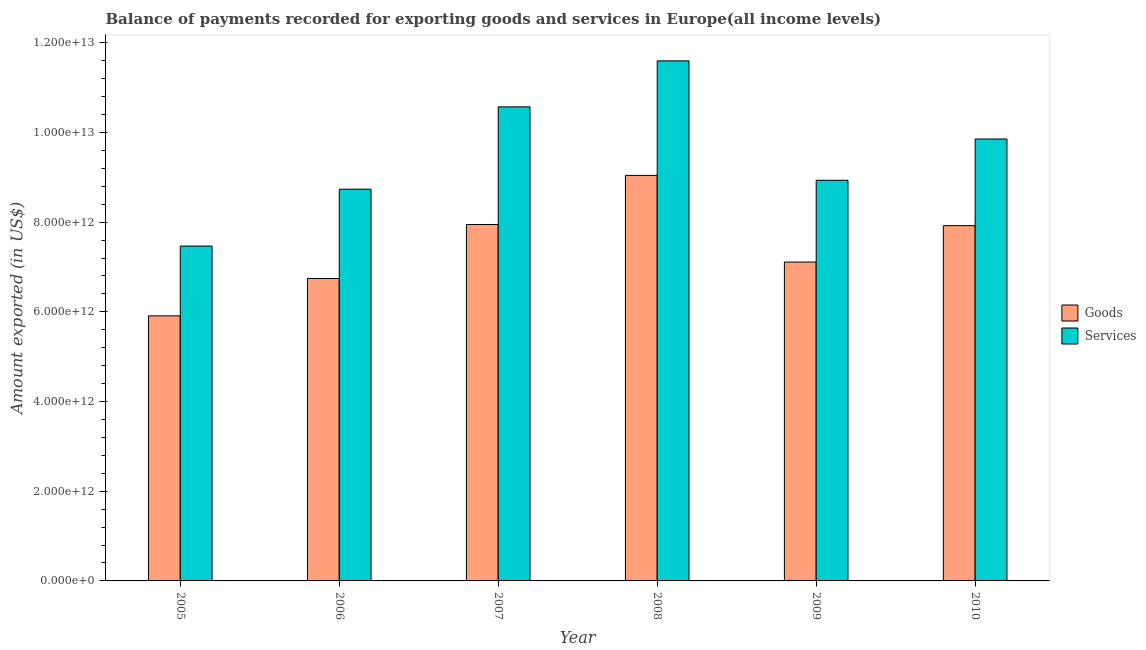Are the number of bars per tick equal to the number of legend labels?
Provide a short and direct response. Yes. Are the number of bars on each tick of the X-axis equal?
Keep it short and to the point. Yes. How many bars are there on the 5th tick from the right?
Keep it short and to the point. 2. What is the label of the 1st group of bars from the left?
Provide a succinct answer. 2005. What is the amount of goods exported in 2010?
Provide a short and direct response. 7.92e+12. Across all years, what is the maximum amount of goods exported?
Your answer should be compact. 9.04e+12. Across all years, what is the minimum amount of goods exported?
Your answer should be compact. 5.91e+12. What is the total amount of goods exported in the graph?
Offer a very short reply. 4.47e+13. What is the difference between the amount of goods exported in 2006 and that in 2010?
Keep it short and to the point. -1.18e+12. What is the difference between the amount of services exported in 2006 and the amount of goods exported in 2007?
Keep it short and to the point. -1.84e+12. What is the average amount of services exported per year?
Offer a terse response. 9.53e+12. What is the ratio of the amount of services exported in 2005 to that in 2008?
Offer a very short reply. 0.64. Is the amount of goods exported in 2006 less than that in 2010?
Offer a very short reply. Yes. Is the difference between the amount of services exported in 2009 and 2010 greater than the difference between the amount of goods exported in 2009 and 2010?
Ensure brevity in your answer.  No. What is the difference between the highest and the second highest amount of services exported?
Offer a very short reply. 1.03e+12. What is the difference between the highest and the lowest amount of services exported?
Give a very brief answer. 4.13e+12. What does the 2nd bar from the left in 2007 represents?
Your answer should be compact. Services. What does the 2nd bar from the right in 2007 represents?
Provide a succinct answer. Goods. How many years are there in the graph?
Keep it short and to the point. 6. What is the difference between two consecutive major ticks on the Y-axis?
Offer a terse response. 2.00e+12. Are the values on the major ticks of Y-axis written in scientific E-notation?
Provide a succinct answer. Yes. Does the graph contain any zero values?
Offer a very short reply. No. Does the graph contain grids?
Offer a terse response. No. Where does the legend appear in the graph?
Your answer should be very brief. Center right. How many legend labels are there?
Keep it short and to the point. 2. How are the legend labels stacked?
Offer a very short reply. Vertical. What is the title of the graph?
Make the answer very short. Balance of payments recorded for exporting goods and services in Europe(all income levels). Does "Rural" appear as one of the legend labels in the graph?
Give a very brief answer. No. What is the label or title of the Y-axis?
Provide a short and direct response. Amount exported (in US$). What is the Amount exported (in US$) of Goods in 2005?
Give a very brief answer. 5.91e+12. What is the Amount exported (in US$) of Services in 2005?
Your response must be concise. 7.47e+12. What is the Amount exported (in US$) of Goods in 2006?
Provide a succinct answer. 6.74e+12. What is the Amount exported (in US$) of Services in 2006?
Make the answer very short. 8.74e+12. What is the Amount exported (in US$) in Goods in 2007?
Ensure brevity in your answer.  7.95e+12. What is the Amount exported (in US$) in Services in 2007?
Your answer should be very brief. 1.06e+13. What is the Amount exported (in US$) in Goods in 2008?
Make the answer very short. 9.04e+12. What is the Amount exported (in US$) in Services in 2008?
Offer a terse response. 1.16e+13. What is the Amount exported (in US$) of Goods in 2009?
Your answer should be very brief. 7.11e+12. What is the Amount exported (in US$) of Services in 2009?
Provide a succinct answer. 8.93e+12. What is the Amount exported (in US$) in Goods in 2010?
Your response must be concise. 7.92e+12. What is the Amount exported (in US$) in Services in 2010?
Your response must be concise. 9.86e+12. Across all years, what is the maximum Amount exported (in US$) in Goods?
Keep it short and to the point. 9.04e+12. Across all years, what is the maximum Amount exported (in US$) in Services?
Offer a terse response. 1.16e+13. Across all years, what is the minimum Amount exported (in US$) of Goods?
Provide a short and direct response. 5.91e+12. Across all years, what is the minimum Amount exported (in US$) in Services?
Give a very brief answer. 7.47e+12. What is the total Amount exported (in US$) of Goods in the graph?
Ensure brevity in your answer.  4.47e+13. What is the total Amount exported (in US$) of Services in the graph?
Ensure brevity in your answer.  5.72e+13. What is the difference between the Amount exported (in US$) in Goods in 2005 and that in 2006?
Make the answer very short. -8.34e+11. What is the difference between the Amount exported (in US$) of Services in 2005 and that in 2006?
Keep it short and to the point. -1.27e+12. What is the difference between the Amount exported (in US$) of Goods in 2005 and that in 2007?
Offer a very short reply. -2.04e+12. What is the difference between the Amount exported (in US$) in Services in 2005 and that in 2007?
Provide a succinct answer. -3.10e+12. What is the difference between the Amount exported (in US$) of Goods in 2005 and that in 2008?
Offer a very short reply. -3.13e+12. What is the difference between the Amount exported (in US$) of Services in 2005 and that in 2008?
Provide a short and direct response. -4.13e+12. What is the difference between the Amount exported (in US$) of Goods in 2005 and that in 2009?
Provide a succinct answer. -1.20e+12. What is the difference between the Amount exported (in US$) of Services in 2005 and that in 2009?
Make the answer very short. -1.47e+12. What is the difference between the Amount exported (in US$) in Goods in 2005 and that in 2010?
Make the answer very short. -2.01e+12. What is the difference between the Amount exported (in US$) of Services in 2005 and that in 2010?
Provide a succinct answer. -2.39e+12. What is the difference between the Amount exported (in US$) of Goods in 2006 and that in 2007?
Your response must be concise. -1.20e+12. What is the difference between the Amount exported (in US$) of Services in 2006 and that in 2007?
Give a very brief answer. -1.84e+12. What is the difference between the Amount exported (in US$) in Goods in 2006 and that in 2008?
Your answer should be very brief. -2.30e+12. What is the difference between the Amount exported (in US$) of Services in 2006 and that in 2008?
Make the answer very short. -2.86e+12. What is the difference between the Amount exported (in US$) of Goods in 2006 and that in 2009?
Make the answer very short. -3.67e+11. What is the difference between the Amount exported (in US$) of Services in 2006 and that in 2009?
Your response must be concise. -1.99e+11. What is the difference between the Amount exported (in US$) of Goods in 2006 and that in 2010?
Provide a short and direct response. -1.18e+12. What is the difference between the Amount exported (in US$) in Services in 2006 and that in 2010?
Offer a very short reply. -1.12e+12. What is the difference between the Amount exported (in US$) in Goods in 2007 and that in 2008?
Your response must be concise. -1.09e+12. What is the difference between the Amount exported (in US$) of Services in 2007 and that in 2008?
Give a very brief answer. -1.03e+12. What is the difference between the Amount exported (in US$) of Goods in 2007 and that in 2009?
Your answer should be compact. 8.38e+11. What is the difference between the Amount exported (in US$) in Services in 2007 and that in 2009?
Provide a short and direct response. 1.64e+12. What is the difference between the Amount exported (in US$) of Goods in 2007 and that in 2010?
Keep it short and to the point. 2.57e+1. What is the difference between the Amount exported (in US$) of Services in 2007 and that in 2010?
Ensure brevity in your answer.  7.16e+11. What is the difference between the Amount exported (in US$) in Goods in 2008 and that in 2009?
Your answer should be very brief. 1.93e+12. What is the difference between the Amount exported (in US$) of Services in 2008 and that in 2009?
Your response must be concise. 2.66e+12. What is the difference between the Amount exported (in US$) of Goods in 2008 and that in 2010?
Keep it short and to the point. 1.12e+12. What is the difference between the Amount exported (in US$) of Services in 2008 and that in 2010?
Give a very brief answer. 1.74e+12. What is the difference between the Amount exported (in US$) in Goods in 2009 and that in 2010?
Give a very brief answer. -8.12e+11. What is the difference between the Amount exported (in US$) of Services in 2009 and that in 2010?
Your answer should be very brief. -9.21e+11. What is the difference between the Amount exported (in US$) in Goods in 2005 and the Amount exported (in US$) in Services in 2006?
Give a very brief answer. -2.82e+12. What is the difference between the Amount exported (in US$) in Goods in 2005 and the Amount exported (in US$) in Services in 2007?
Keep it short and to the point. -4.66e+12. What is the difference between the Amount exported (in US$) of Goods in 2005 and the Amount exported (in US$) of Services in 2008?
Give a very brief answer. -5.69e+12. What is the difference between the Amount exported (in US$) of Goods in 2005 and the Amount exported (in US$) of Services in 2009?
Ensure brevity in your answer.  -3.02e+12. What is the difference between the Amount exported (in US$) in Goods in 2005 and the Amount exported (in US$) in Services in 2010?
Your response must be concise. -3.94e+12. What is the difference between the Amount exported (in US$) of Goods in 2006 and the Amount exported (in US$) of Services in 2007?
Give a very brief answer. -3.83e+12. What is the difference between the Amount exported (in US$) of Goods in 2006 and the Amount exported (in US$) of Services in 2008?
Your answer should be compact. -4.85e+12. What is the difference between the Amount exported (in US$) of Goods in 2006 and the Amount exported (in US$) of Services in 2009?
Offer a very short reply. -2.19e+12. What is the difference between the Amount exported (in US$) in Goods in 2006 and the Amount exported (in US$) in Services in 2010?
Ensure brevity in your answer.  -3.11e+12. What is the difference between the Amount exported (in US$) in Goods in 2007 and the Amount exported (in US$) in Services in 2008?
Provide a short and direct response. -3.65e+12. What is the difference between the Amount exported (in US$) of Goods in 2007 and the Amount exported (in US$) of Services in 2009?
Keep it short and to the point. -9.86e+11. What is the difference between the Amount exported (in US$) in Goods in 2007 and the Amount exported (in US$) in Services in 2010?
Make the answer very short. -1.91e+12. What is the difference between the Amount exported (in US$) in Goods in 2008 and the Amount exported (in US$) in Services in 2009?
Provide a short and direct response. 1.09e+11. What is the difference between the Amount exported (in US$) in Goods in 2008 and the Amount exported (in US$) in Services in 2010?
Ensure brevity in your answer.  -8.12e+11. What is the difference between the Amount exported (in US$) of Goods in 2009 and the Amount exported (in US$) of Services in 2010?
Your answer should be very brief. -2.74e+12. What is the average Amount exported (in US$) in Goods per year?
Ensure brevity in your answer.  7.45e+12. What is the average Amount exported (in US$) of Services per year?
Keep it short and to the point. 9.53e+12. In the year 2005, what is the difference between the Amount exported (in US$) of Goods and Amount exported (in US$) of Services?
Offer a terse response. -1.56e+12. In the year 2006, what is the difference between the Amount exported (in US$) in Goods and Amount exported (in US$) in Services?
Your answer should be very brief. -1.99e+12. In the year 2007, what is the difference between the Amount exported (in US$) in Goods and Amount exported (in US$) in Services?
Make the answer very short. -2.62e+12. In the year 2008, what is the difference between the Amount exported (in US$) of Goods and Amount exported (in US$) of Services?
Your answer should be compact. -2.55e+12. In the year 2009, what is the difference between the Amount exported (in US$) in Goods and Amount exported (in US$) in Services?
Offer a very short reply. -1.82e+12. In the year 2010, what is the difference between the Amount exported (in US$) of Goods and Amount exported (in US$) of Services?
Ensure brevity in your answer.  -1.93e+12. What is the ratio of the Amount exported (in US$) in Goods in 2005 to that in 2006?
Keep it short and to the point. 0.88. What is the ratio of the Amount exported (in US$) in Services in 2005 to that in 2006?
Keep it short and to the point. 0.85. What is the ratio of the Amount exported (in US$) in Goods in 2005 to that in 2007?
Ensure brevity in your answer.  0.74. What is the ratio of the Amount exported (in US$) of Services in 2005 to that in 2007?
Your response must be concise. 0.71. What is the ratio of the Amount exported (in US$) of Goods in 2005 to that in 2008?
Give a very brief answer. 0.65. What is the ratio of the Amount exported (in US$) of Services in 2005 to that in 2008?
Offer a terse response. 0.64. What is the ratio of the Amount exported (in US$) in Goods in 2005 to that in 2009?
Your answer should be compact. 0.83. What is the ratio of the Amount exported (in US$) of Services in 2005 to that in 2009?
Ensure brevity in your answer.  0.84. What is the ratio of the Amount exported (in US$) of Goods in 2005 to that in 2010?
Offer a terse response. 0.75. What is the ratio of the Amount exported (in US$) of Services in 2005 to that in 2010?
Make the answer very short. 0.76. What is the ratio of the Amount exported (in US$) of Goods in 2006 to that in 2007?
Your answer should be very brief. 0.85. What is the ratio of the Amount exported (in US$) of Services in 2006 to that in 2007?
Offer a very short reply. 0.83. What is the ratio of the Amount exported (in US$) of Goods in 2006 to that in 2008?
Provide a short and direct response. 0.75. What is the ratio of the Amount exported (in US$) in Services in 2006 to that in 2008?
Offer a terse response. 0.75. What is the ratio of the Amount exported (in US$) of Goods in 2006 to that in 2009?
Offer a very short reply. 0.95. What is the ratio of the Amount exported (in US$) of Services in 2006 to that in 2009?
Make the answer very short. 0.98. What is the ratio of the Amount exported (in US$) of Goods in 2006 to that in 2010?
Provide a short and direct response. 0.85. What is the ratio of the Amount exported (in US$) of Services in 2006 to that in 2010?
Give a very brief answer. 0.89. What is the ratio of the Amount exported (in US$) in Goods in 2007 to that in 2008?
Offer a terse response. 0.88. What is the ratio of the Amount exported (in US$) of Services in 2007 to that in 2008?
Give a very brief answer. 0.91. What is the ratio of the Amount exported (in US$) in Goods in 2007 to that in 2009?
Give a very brief answer. 1.12. What is the ratio of the Amount exported (in US$) in Services in 2007 to that in 2009?
Your response must be concise. 1.18. What is the ratio of the Amount exported (in US$) of Services in 2007 to that in 2010?
Give a very brief answer. 1.07. What is the ratio of the Amount exported (in US$) in Goods in 2008 to that in 2009?
Give a very brief answer. 1.27. What is the ratio of the Amount exported (in US$) of Services in 2008 to that in 2009?
Offer a terse response. 1.3. What is the ratio of the Amount exported (in US$) of Goods in 2008 to that in 2010?
Give a very brief answer. 1.14. What is the ratio of the Amount exported (in US$) in Services in 2008 to that in 2010?
Make the answer very short. 1.18. What is the ratio of the Amount exported (in US$) of Goods in 2009 to that in 2010?
Provide a succinct answer. 0.9. What is the ratio of the Amount exported (in US$) in Services in 2009 to that in 2010?
Your response must be concise. 0.91. What is the difference between the highest and the second highest Amount exported (in US$) in Goods?
Provide a short and direct response. 1.09e+12. What is the difference between the highest and the second highest Amount exported (in US$) of Services?
Your response must be concise. 1.03e+12. What is the difference between the highest and the lowest Amount exported (in US$) of Goods?
Ensure brevity in your answer.  3.13e+12. What is the difference between the highest and the lowest Amount exported (in US$) in Services?
Offer a terse response. 4.13e+12. 